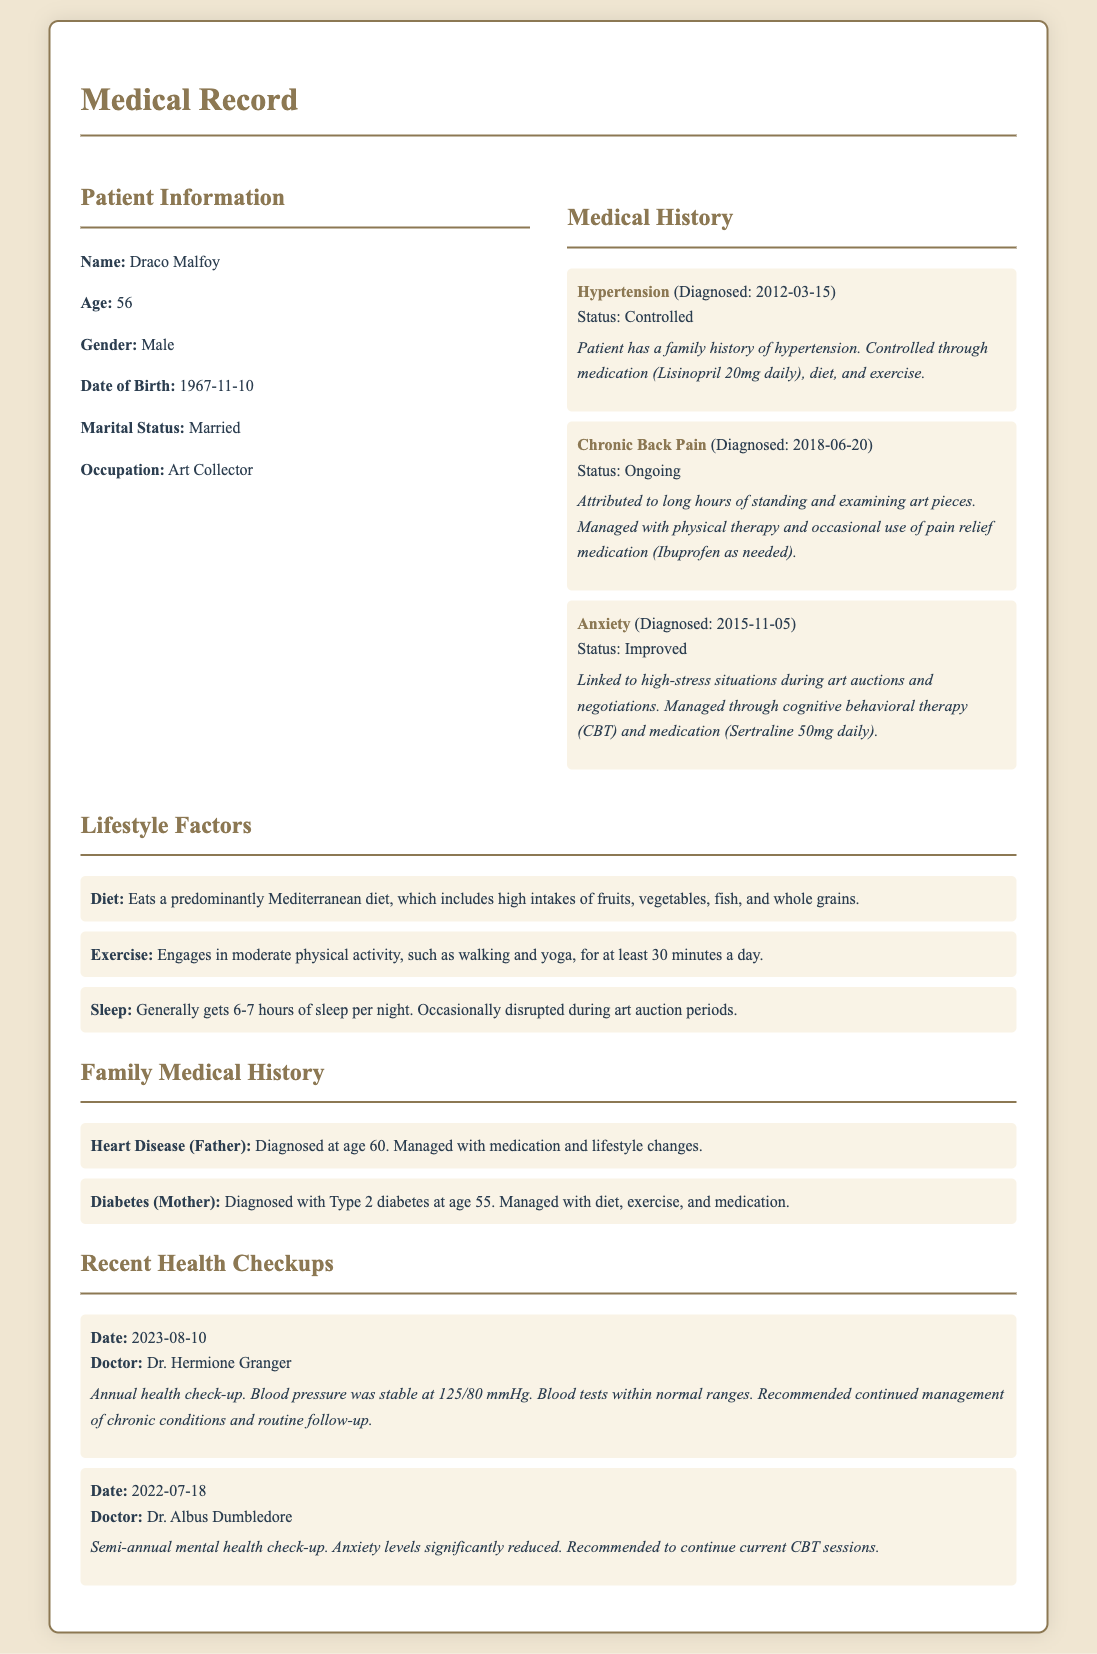what is the name of the patient? The patient's name is provided in the patient information section of the document.
Answer: Draco Malfoy how old is Draco Malfoy? The age of Draco Malfoy is mentioned clearly under the patient information section.
Answer: 56 when was hypertension diagnosed? The diagnosis date for hypertension is found in the medical history section.
Answer: 2012-03-15 what is the status of chronic back pain? The current status of chronic back pain is included in the medical history section.
Answer: Ongoing who conducted the recent health check-up? The name of the doctor who conducted the most recent health check-up is listed in the recent checkups section.
Answer: Dr. Hermione Granger which therapy is used to manage anxiety? The type of therapy mentioned for managing anxiety is included in the medical history section.
Answer: Cognitive behavioral therapy (CBT) what diet does Draco Malfoy follow? The type of diet is described in the lifestyle factors section of the document.
Answer: Predominantly Mediterranean diet what is the blood pressure reading from the latest check-up? The blood pressure reading from the annual health check-up is noted in the recent checkups section.
Answer: 125/80 mmHg how is hypertension managed? The method of managing hypertension is explained in the medical history section.
Answer: Medication, diet, and exercise 